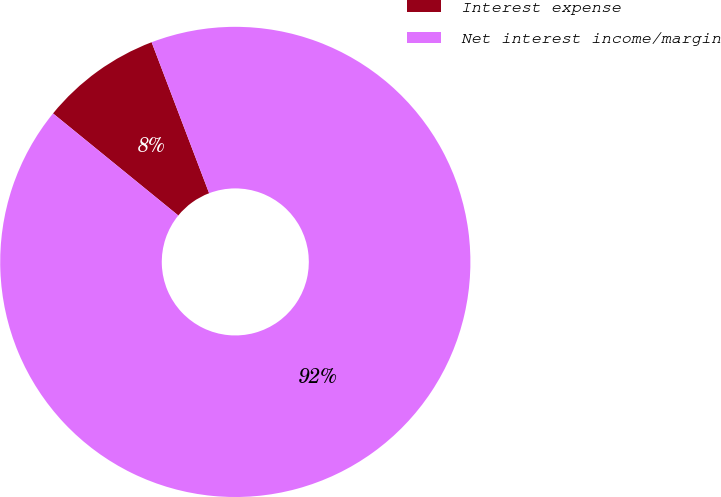Convert chart. <chart><loc_0><loc_0><loc_500><loc_500><pie_chart><fcel>Interest expense<fcel>Net interest income/margin<nl><fcel>8.33%<fcel>91.67%<nl></chart> 